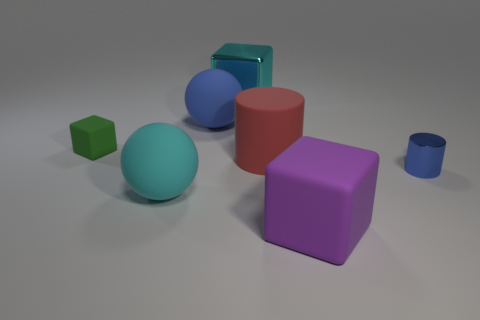What is the big purple object made of? While I cannot feel or directly examine the object, the big purple object in the image resembles a cube and appears to be made with a smooth, matte surface that could be a representation of a material like plastic or a digitally rendered surface in a 3D model. 